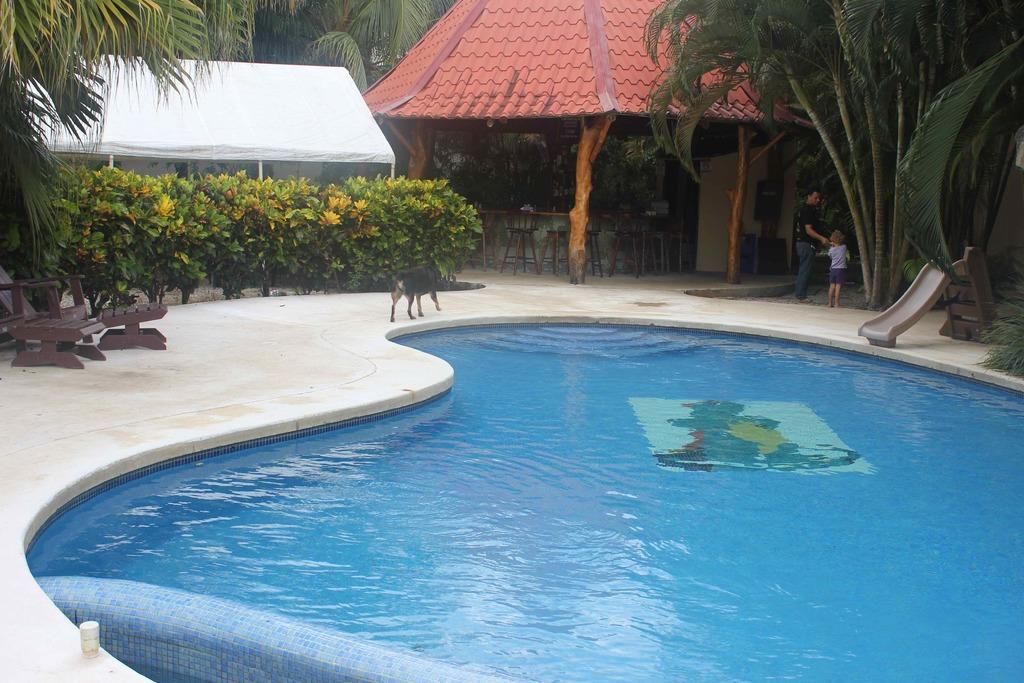How would you summarize this image in a sentence or two? In this picture I can see at the bottom there is a swimming pool. On the right side there are trees and two persons are standing, in the middle it looks like there are garden shelters and there is an animal. On the left side there are chairs and bushes. 